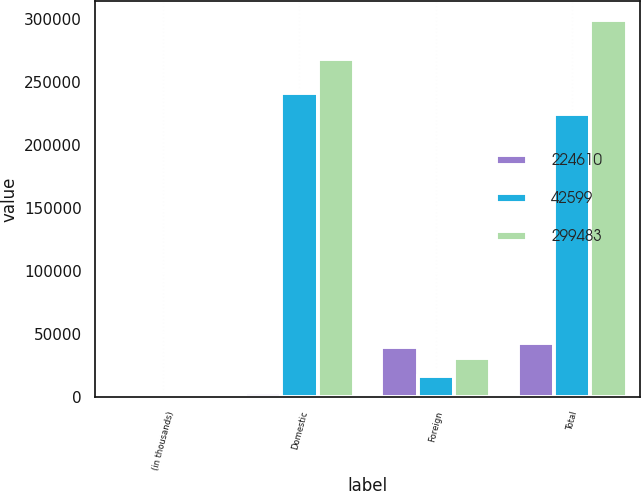<chart> <loc_0><loc_0><loc_500><loc_500><stacked_bar_chart><ecel><fcel>(in thousands)<fcel>Domestic<fcel>Foreign<fcel>Total<nl><fcel>224610<fcel>2002<fcel>3067<fcel>39532<fcel>42599<nl><fcel>42599<fcel>2001<fcel>241479<fcel>16869<fcel>224610<nl><fcel>299483<fcel>2000<fcel>268489<fcel>30994<fcel>299483<nl></chart> 